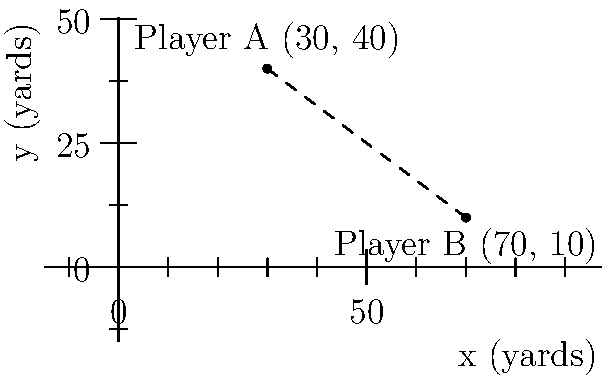On a football field represented by a coordinate system where each unit equals 1 yard, Player A is at position (30, 40) and Player B is at (70, 10). Calculate the straight-line distance between these two players. To find the distance between two points in a coordinate system, we can use the distance formula, which is derived from the Pythagorean theorem:

1. The distance formula is: $d = \sqrt{(x_2 - x_1)^2 + (y_2 - y_1)^2}$

2. Let's identify our points:
   Player A: $(x_1, y_1) = (30, 40)$
   Player B: $(x_2, y_2) = (70, 10)$

3. Now, let's plug these values into the formula:
   $d = \sqrt{(70 - 30)^2 + (10 - 40)^2}$

4. Simplify inside the parentheses:
   $d = \sqrt{(40)^2 + (-30)^2}$

5. Calculate the squares:
   $d = \sqrt{1600 + 900}$

6. Add inside the square root:
   $d = \sqrt{2500}$

7. Simplify the square root:
   $d = 50$

Therefore, the straight-line distance between Player A and Player B is 50 yards.
Answer: 50 yards 